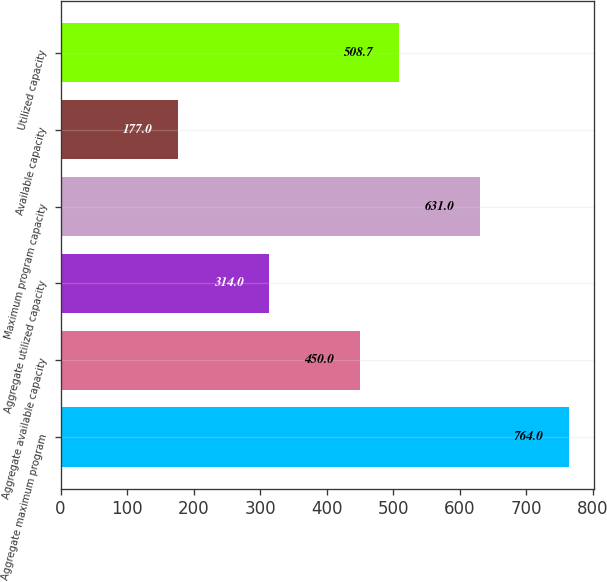Convert chart. <chart><loc_0><loc_0><loc_500><loc_500><bar_chart><fcel>Aggregate maximum program<fcel>Aggregate available capacity<fcel>Aggregate utilized capacity<fcel>Maximum program capacity<fcel>Available capacity<fcel>Utilized capacity<nl><fcel>764<fcel>450<fcel>314<fcel>631<fcel>177<fcel>508.7<nl></chart> 